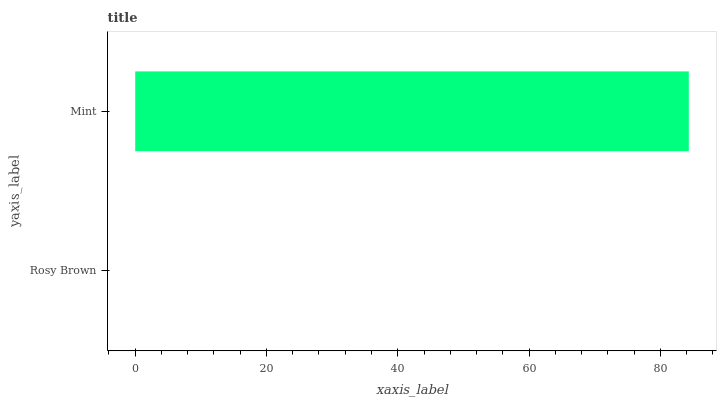Is Rosy Brown the minimum?
Answer yes or no. Yes. Is Mint the maximum?
Answer yes or no. Yes. Is Mint the minimum?
Answer yes or no. No. Is Mint greater than Rosy Brown?
Answer yes or no. Yes. Is Rosy Brown less than Mint?
Answer yes or no. Yes. Is Rosy Brown greater than Mint?
Answer yes or no. No. Is Mint less than Rosy Brown?
Answer yes or no. No. Is Mint the high median?
Answer yes or no. Yes. Is Rosy Brown the low median?
Answer yes or no. Yes. Is Rosy Brown the high median?
Answer yes or no. No. Is Mint the low median?
Answer yes or no. No. 